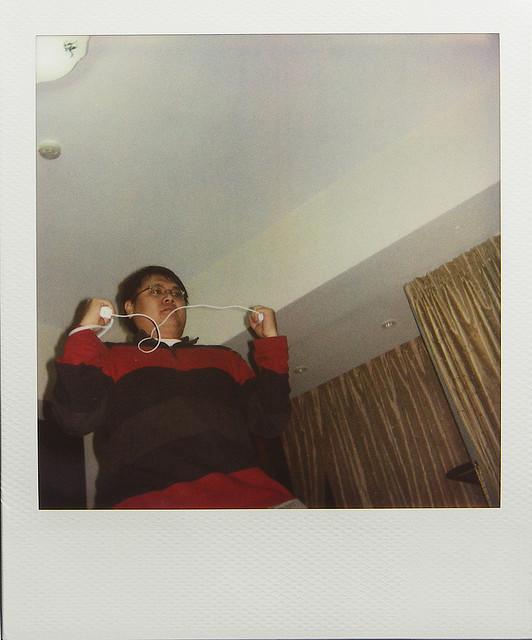Is the camera that took this picture from the same era of history as the boy's activity?
Quick response, please. No. What color are the curtains?
Concise answer only. Gold. What kind of photograph is featured here?
Write a very short answer. Polaroid. 